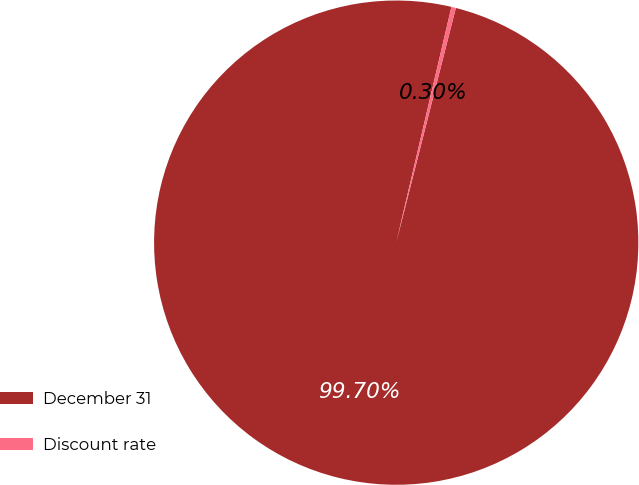<chart> <loc_0><loc_0><loc_500><loc_500><pie_chart><fcel>December 31<fcel>Discount rate<nl><fcel>99.7%<fcel>0.3%<nl></chart> 